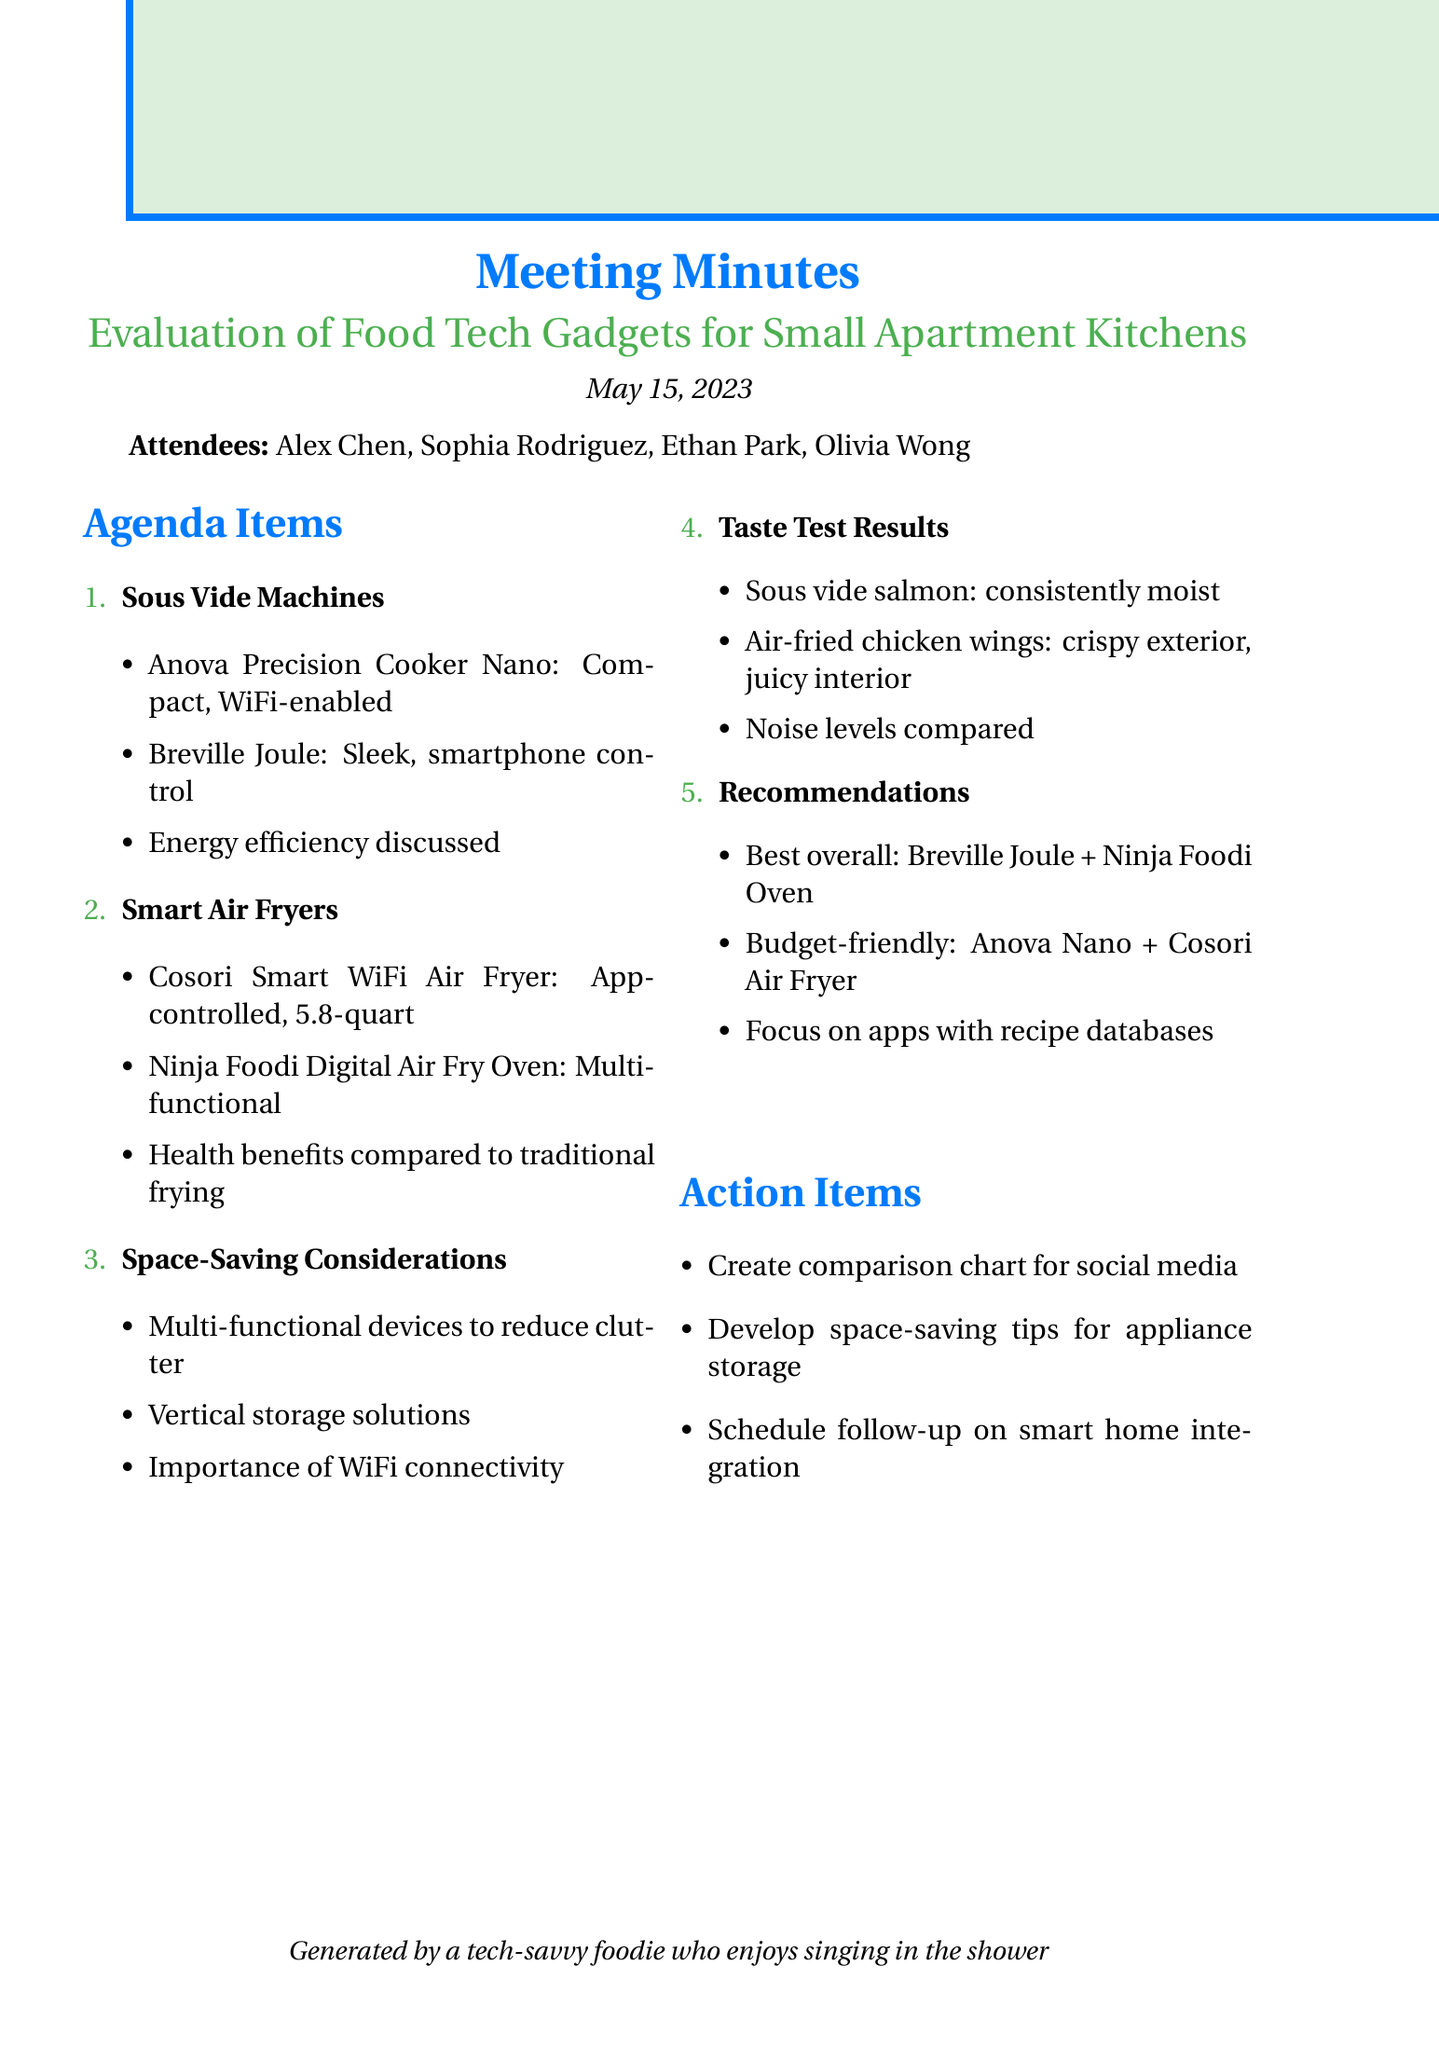What was the date of the meeting? The date of the meeting is explicitly mentioned in the document.
Answer: May 15, 2023 Who is one of the attendees? The attendees are listed in the document, and any name can be chosen.
Answer: Alex Chen What is one recommended gadget for sous vide cooking? The discussions in the document highlight various gadgets, one of which can be chosen.
Answer: Breville Joule What is the capacity of the Cosori Smart WiFi Air Fryer? The document specifies the capacity of this air fryer.
Answer: 5.8-quart Which sous vide machine is considered budget-friendly? The document provides a specific recommendation for a budget-friendly gadget.
Answer: Anova Precision Cooker Nano What was one taste test result for the air-fried chicken wings? The taste test results detail specific outcomes from the cooking tests.
Answer: Crispy exterior, juicy interior What is a key consideration for small kitchen appliances mentioned in the meeting? The document discusses various considerations for kitchen appliance usage in small spaces.
Answer: Multi-functional devices to reduce clutter How many action items are listed in the document? Action items are enumerated in the document, the total can be counted.
Answer: Three 